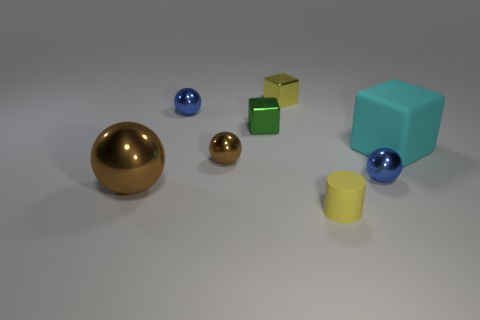What number of other things are the same color as the small matte object?
Your answer should be compact. 1. Is there a tiny brown cylinder made of the same material as the tiny green cube?
Keep it short and to the point. No. How many objects are things on the right side of the tiny matte thing or tiny yellow objects?
Make the answer very short. 4. Are any big yellow matte things visible?
Provide a succinct answer. No. What shape is the object that is both to the left of the tiny brown thing and on the right side of the large brown metallic thing?
Provide a succinct answer. Sphere. How big is the blue object that is to the left of the yellow block?
Ensure brevity in your answer.  Small. There is a tiny block that is right of the small green shiny cube; is its color the same as the small cylinder?
Offer a terse response. Yes. What number of big brown things have the same shape as the small yellow shiny thing?
Offer a terse response. 0. How many things are tiny metal balls that are on the right side of the yellow metallic block or small balls to the right of the tiny yellow metal cube?
Offer a terse response. 1. How many brown things are tiny metal balls or large rubber blocks?
Offer a very short reply. 1. 